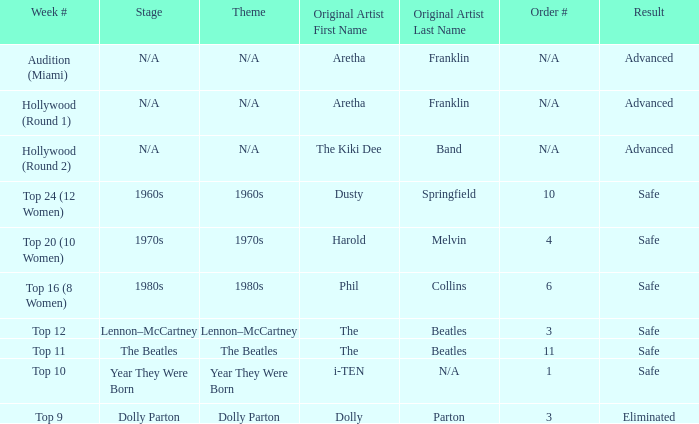Can you parse all the data within this table? {'header': ['Week #', 'Stage', 'Theme', 'Original Artist First Name', 'Original Artist Last Name', 'Order #', 'Result'], 'rows': [['Audition (Miami)', 'N/A', 'N/A', 'Aretha', 'Franklin', 'N/A', 'Advanced'], ['Hollywood (Round 1)', 'N/A', 'N/A', 'Aretha', 'Franklin', 'N/A', 'Advanced'], ['Hollywood (Round 2)', 'N/A', 'N/A', 'The Kiki Dee', 'Band', 'N/A', 'Advanced'], ['Top 24 (12 Women)', '1960s', '1960s', 'Dusty', 'Springfield', '10', 'Safe'], ['Top 20 (10 Women)', '1970s', '1970s', 'Harold', 'Melvin', '4', 'Safe'], ['Top 16 (8 Women)', '1980s', '1980s', 'Phil', 'Collins', '6', 'Safe'], ['Top 12', 'Lennon–McCartney', 'Lennon–McCartney', 'The', 'Beatles', '3', 'Safe'], ['Top 11', 'The Beatles', 'The Beatles', 'The', 'Beatles', '11', 'Safe'], ['Top 10', 'Year They Were Born', 'Year They Were Born', 'i-TEN', 'N/A', '1', 'Safe'], ['Top 9', 'Dolly Parton', 'Dolly Parton', 'Dolly', 'Parton', '3', 'Eliminated']]} What is the original artist that has 11 as the order number? The Beatles. 